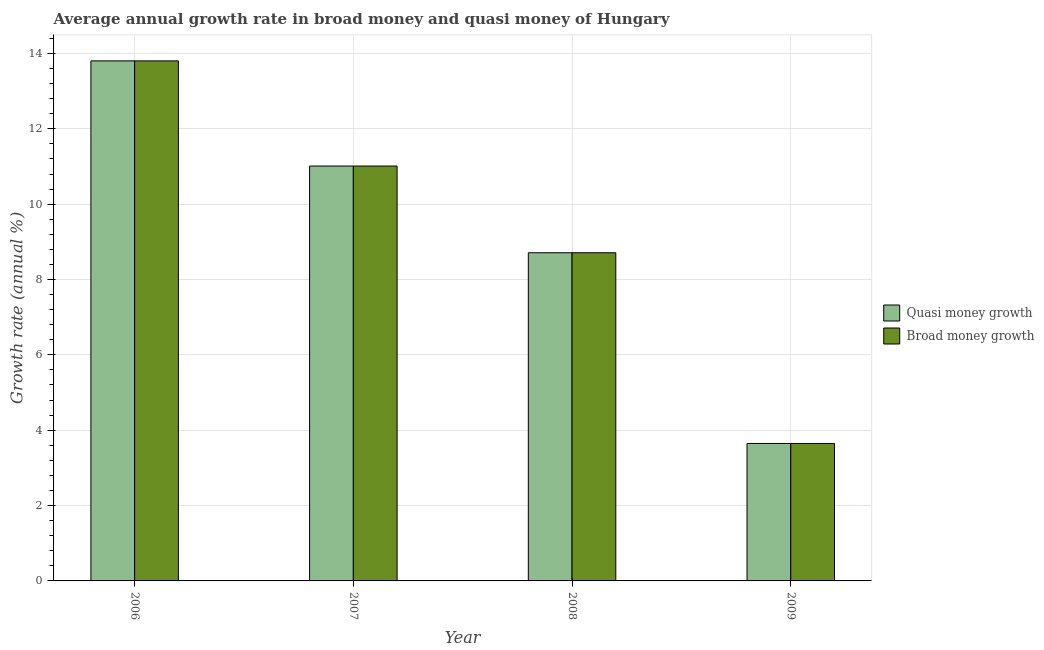How many groups of bars are there?
Offer a very short reply. 4. Are the number of bars per tick equal to the number of legend labels?
Ensure brevity in your answer.  Yes. Are the number of bars on each tick of the X-axis equal?
Your answer should be very brief. Yes. In how many cases, is the number of bars for a given year not equal to the number of legend labels?
Give a very brief answer. 0. What is the annual growth rate in quasi money in 2006?
Provide a succinct answer. 13.8. Across all years, what is the maximum annual growth rate in broad money?
Your response must be concise. 13.8. Across all years, what is the minimum annual growth rate in quasi money?
Your answer should be compact. 3.65. In which year was the annual growth rate in broad money minimum?
Your answer should be compact. 2009. What is the total annual growth rate in quasi money in the graph?
Your answer should be compact. 37.17. What is the difference between the annual growth rate in broad money in 2007 and that in 2009?
Provide a succinct answer. 7.36. What is the difference between the annual growth rate in broad money in 2006 and the annual growth rate in quasi money in 2009?
Give a very brief answer. 10.15. What is the average annual growth rate in broad money per year?
Your response must be concise. 9.29. In the year 2006, what is the difference between the annual growth rate in broad money and annual growth rate in quasi money?
Give a very brief answer. 0. In how many years, is the annual growth rate in broad money greater than 5.6 %?
Make the answer very short. 3. What is the ratio of the annual growth rate in broad money in 2007 to that in 2009?
Your answer should be compact. 3.02. Is the annual growth rate in broad money in 2006 less than that in 2009?
Ensure brevity in your answer.  No. Is the difference between the annual growth rate in broad money in 2006 and 2008 greater than the difference between the annual growth rate in quasi money in 2006 and 2008?
Provide a short and direct response. No. What is the difference between the highest and the second highest annual growth rate in broad money?
Give a very brief answer. 2.79. What is the difference between the highest and the lowest annual growth rate in quasi money?
Provide a succinct answer. 10.15. What does the 2nd bar from the left in 2009 represents?
Provide a succinct answer. Broad money growth. What does the 2nd bar from the right in 2007 represents?
Your answer should be compact. Quasi money growth. Are all the bars in the graph horizontal?
Offer a very short reply. No. How many years are there in the graph?
Make the answer very short. 4. What is the difference between two consecutive major ticks on the Y-axis?
Offer a terse response. 2. Are the values on the major ticks of Y-axis written in scientific E-notation?
Give a very brief answer. No. How many legend labels are there?
Your answer should be very brief. 2. How are the legend labels stacked?
Offer a very short reply. Vertical. What is the title of the graph?
Give a very brief answer. Average annual growth rate in broad money and quasi money of Hungary. Does "Taxes on exports" appear as one of the legend labels in the graph?
Give a very brief answer. No. What is the label or title of the X-axis?
Ensure brevity in your answer.  Year. What is the label or title of the Y-axis?
Provide a succinct answer. Growth rate (annual %). What is the Growth rate (annual %) of Quasi money growth in 2006?
Offer a very short reply. 13.8. What is the Growth rate (annual %) of Broad money growth in 2006?
Ensure brevity in your answer.  13.8. What is the Growth rate (annual %) of Quasi money growth in 2007?
Keep it short and to the point. 11.01. What is the Growth rate (annual %) in Broad money growth in 2007?
Offer a terse response. 11.01. What is the Growth rate (annual %) in Quasi money growth in 2008?
Your response must be concise. 8.71. What is the Growth rate (annual %) in Broad money growth in 2008?
Offer a terse response. 8.71. What is the Growth rate (annual %) in Quasi money growth in 2009?
Keep it short and to the point. 3.65. What is the Growth rate (annual %) in Broad money growth in 2009?
Keep it short and to the point. 3.65. Across all years, what is the maximum Growth rate (annual %) in Quasi money growth?
Keep it short and to the point. 13.8. Across all years, what is the maximum Growth rate (annual %) of Broad money growth?
Offer a terse response. 13.8. Across all years, what is the minimum Growth rate (annual %) in Quasi money growth?
Your answer should be very brief. 3.65. Across all years, what is the minimum Growth rate (annual %) in Broad money growth?
Your answer should be very brief. 3.65. What is the total Growth rate (annual %) of Quasi money growth in the graph?
Give a very brief answer. 37.17. What is the total Growth rate (annual %) of Broad money growth in the graph?
Ensure brevity in your answer.  37.17. What is the difference between the Growth rate (annual %) in Quasi money growth in 2006 and that in 2007?
Make the answer very short. 2.79. What is the difference between the Growth rate (annual %) in Broad money growth in 2006 and that in 2007?
Your response must be concise. 2.79. What is the difference between the Growth rate (annual %) of Quasi money growth in 2006 and that in 2008?
Make the answer very short. 5.09. What is the difference between the Growth rate (annual %) of Broad money growth in 2006 and that in 2008?
Make the answer very short. 5.09. What is the difference between the Growth rate (annual %) of Quasi money growth in 2006 and that in 2009?
Provide a succinct answer. 10.15. What is the difference between the Growth rate (annual %) in Broad money growth in 2006 and that in 2009?
Keep it short and to the point. 10.15. What is the difference between the Growth rate (annual %) of Quasi money growth in 2007 and that in 2008?
Provide a succinct answer. 2.3. What is the difference between the Growth rate (annual %) in Broad money growth in 2007 and that in 2008?
Keep it short and to the point. 2.3. What is the difference between the Growth rate (annual %) in Quasi money growth in 2007 and that in 2009?
Keep it short and to the point. 7.36. What is the difference between the Growth rate (annual %) in Broad money growth in 2007 and that in 2009?
Offer a terse response. 7.36. What is the difference between the Growth rate (annual %) in Quasi money growth in 2008 and that in 2009?
Offer a very short reply. 5.06. What is the difference between the Growth rate (annual %) in Broad money growth in 2008 and that in 2009?
Your answer should be very brief. 5.06. What is the difference between the Growth rate (annual %) of Quasi money growth in 2006 and the Growth rate (annual %) of Broad money growth in 2007?
Offer a very short reply. 2.79. What is the difference between the Growth rate (annual %) of Quasi money growth in 2006 and the Growth rate (annual %) of Broad money growth in 2008?
Ensure brevity in your answer.  5.09. What is the difference between the Growth rate (annual %) of Quasi money growth in 2006 and the Growth rate (annual %) of Broad money growth in 2009?
Make the answer very short. 10.15. What is the difference between the Growth rate (annual %) of Quasi money growth in 2007 and the Growth rate (annual %) of Broad money growth in 2008?
Offer a terse response. 2.3. What is the difference between the Growth rate (annual %) in Quasi money growth in 2007 and the Growth rate (annual %) in Broad money growth in 2009?
Give a very brief answer. 7.36. What is the difference between the Growth rate (annual %) of Quasi money growth in 2008 and the Growth rate (annual %) of Broad money growth in 2009?
Offer a very short reply. 5.06. What is the average Growth rate (annual %) in Quasi money growth per year?
Keep it short and to the point. 9.29. What is the average Growth rate (annual %) in Broad money growth per year?
Make the answer very short. 9.29. In the year 2009, what is the difference between the Growth rate (annual %) in Quasi money growth and Growth rate (annual %) in Broad money growth?
Keep it short and to the point. 0. What is the ratio of the Growth rate (annual %) of Quasi money growth in 2006 to that in 2007?
Provide a succinct answer. 1.25. What is the ratio of the Growth rate (annual %) in Broad money growth in 2006 to that in 2007?
Offer a very short reply. 1.25. What is the ratio of the Growth rate (annual %) of Quasi money growth in 2006 to that in 2008?
Your response must be concise. 1.58. What is the ratio of the Growth rate (annual %) of Broad money growth in 2006 to that in 2008?
Make the answer very short. 1.58. What is the ratio of the Growth rate (annual %) of Quasi money growth in 2006 to that in 2009?
Ensure brevity in your answer.  3.78. What is the ratio of the Growth rate (annual %) in Broad money growth in 2006 to that in 2009?
Provide a short and direct response. 3.78. What is the ratio of the Growth rate (annual %) of Quasi money growth in 2007 to that in 2008?
Make the answer very short. 1.26. What is the ratio of the Growth rate (annual %) of Broad money growth in 2007 to that in 2008?
Keep it short and to the point. 1.26. What is the ratio of the Growth rate (annual %) in Quasi money growth in 2007 to that in 2009?
Give a very brief answer. 3.02. What is the ratio of the Growth rate (annual %) of Broad money growth in 2007 to that in 2009?
Your response must be concise. 3.02. What is the ratio of the Growth rate (annual %) of Quasi money growth in 2008 to that in 2009?
Your response must be concise. 2.39. What is the ratio of the Growth rate (annual %) of Broad money growth in 2008 to that in 2009?
Your answer should be compact. 2.39. What is the difference between the highest and the second highest Growth rate (annual %) in Quasi money growth?
Make the answer very short. 2.79. What is the difference between the highest and the second highest Growth rate (annual %) of Broad money growth?
Keep it short and to the point. 2.79. What is the difference between the highest and the lowest Growth rate (annual %) in Quasi money growth?
Make the answer very short. 10.15. What is the difference between the highest and the lowest Growth rate (annual %) in Broad money growth?
Your response must be concise. 10.15. 